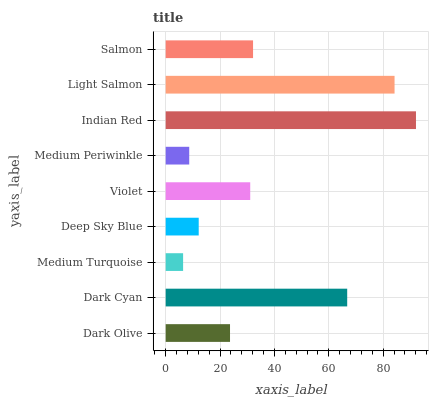Is Medium Turquoise the minimum?
Answer yes or no. Yes. Is Indian Red the maximum?
Answer yes or no. Yes. Is Dark Cyan the minimum?
Answer yes or no. No. Is Dark Cyan the maximum?
Answer yes or no. No. Is Dark Cyan greater than Dark Olive?
Answer yes or no. Yes. Is Dark Olive less than Dark Cyan?
Answer yes or no. Yes. Is Dark Olive greater than Dark Cyan?
Answer yes or no. No. Is Dark Cyan less than Dark Olive?
Answer yes or no. No. Is Violet the high median?
Answer yes or no. Yes. Is Violet the low median?
Answer yes or no. Yes. Is Deep Sky Blue the high median?
Answer yes or no. No. Is Salmon the low median?
Answer yes or no. No. 